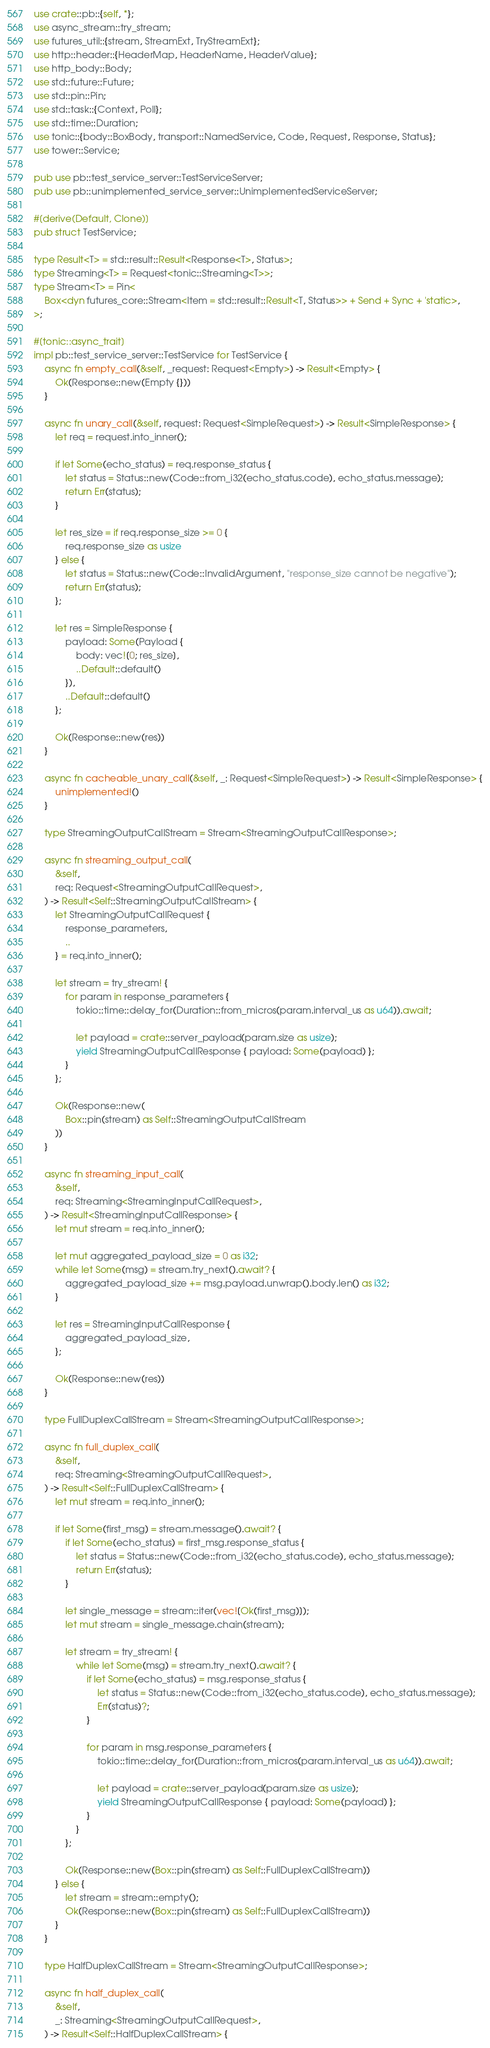Convert code to text. <code><loc_0><loc_0><loc_500><loc_500><_Rust_>use crate::pb::{self, *};
use async_stream::try_stream;
use futures_util::{stream, StreamExt, TryStreamExt};
use http::header::{HeaderMap, HeaderName, HeaderValue};
use http_body::Body;
use std::future::Future;
use std::pin::Pin;
use std::task::{Context, Poll};
use std::time::Duration;
use tonic::{body::BoxBody, transport::NamedService, Code, Request, Response, Status};
use tower::Service;

pub use pb::test_service_server::TestServiceServer;
pub use pb::unimplemented_service_server::UnimplementedServiceServer;

#[derive(Default, Clone)]
pub struct TestService;

type Result<T> = std::result::Result<Response<T>, Status>;
type Streaming<T> = Request<tonic::Streaming<T>>;
type Stream<T> = Pin<
    Box<dyn futures_core::Stream<Item = std::result::Result<T, Status>> + Send + Sync + 'static>,
>;

#[tonic::async_trait]
impl pb::test_service_server::TestService for TestService {
    async fn empty_call(&self, _request: Request<Empty>) -> Result<Empty> {
        Ok(Response::new(Empty {}))
    }

    async fn unary_call(&self, request: Request<SimpleRequest>) -> Result<SimpleResponse> {
        let req = request.into_inner();

        if let Some(echo_status) = req.response_status {
            let status = Status::new(Code::from_i32(echo_status.code), echo_status.message);
            return Err(status);
        }

        let res_size = if req.response_size >= 0 {
            req.response_size as usize
        } else {
            let status = Status::new(Code::InvalidArgument, "response_size cannot be negative");
            return Err(status);
        };

        let res = SimpleResponse {
            payload: Some(Payload {
                body: vec![0; res_size],
                ..Default::default()
            }),
            ..Default::default()
        };

        Ok(Response::new(res))
    }

    async fn cacheable_unary_call(&self, _: Request<SimpleRequest>) -> Result<SimpleResponse> {
        unimplemented!()
    }

    type StreamingOutputCallStream = Stream<StreamingOutputCallResponse>;

    async fn streaming_output_call(
        &self,
        req: Request<StreamingOutputCallRequest>,
    ) -> Result<Self::StreamingOutputCallStream> {
        let StreamingOutputCallRequest {
            response_parameters,
            ..
        } = req.into_inner();

        let stream = try_stream! {
            for param in response_parameters {
                tokio::time::delay_for(Duration::from_micros(param.interval_us as u64)).await;

                let payload = crate::server_payload(param.size as usize);
                yield StreamingOutputCallResponse { payload: Some(payload) };
            }
        };

        Ok(Response::new(
            Box::pin(stream) as Self::StreamingOutputCallStream
        ))
    }

    async fn streaming_input_call(
        &self,
        req: Streaming<StreamingInputCallRequest>,
    ) -> Result<StreamingInputCallResponse> {
        let mut stream = req.into_inner();

        let mut aggregated_payload_size = 0 as i32;
        while let Some(msg) = stream.try_next().await? {
            aggregated_payload_size += msg.payload.unwrap().body.len() as i32;
        }

        let res = StreamingInputCallResponse {
            aggregated_payload_size,
        };

        Ok(Response::new(res))
    }

    type FullDuplexCallStream = Stream<StreamingOutputCallResponse>;

    async fn full_duplex_call(
        &self,
        req: Streaming<StreamingOutputCallRequest>,
    ) -> Result<Self::FullDuplexCallStream> {
        let mut stream = req.into_inner();

        if let Some(first_msg) = stream.message().await? {
            if let Some(echo_status) = first_msg.response_status {
                let status = Status::new(Code::from_i32(echo_status.code), echo_status.message);
                return Err(status);
            }

            let single_message = stream::iter(vec![Ok(first_msg)]);
            let mut stream = single_message.chain(stream);

            let stream = try_stream! {
                while let Some(msg) = stream.try_next().await? {
                    if let Some(echo_status) = msg.response_status {
                        let status = Status::new(Code::from_i32(echo_status.code), echo_status.message);
                        Err(status)?;
                    }

                    for param in msg.response_parameters {
                        tokio::time::delay_for(Duration::from_micros(param.interval_us as u64)).await;

                        let payload = crate::server_payload(param.size as usize);
                        yield StreamingOutputCallResponse { payload: Some(payload) };
                    }
                }
            };

            Ok(Response::new(Box::pin(stream) as Self::FullDuplexCallStream))
        } else {
            let stream = stream::empty();
            Ok(Response::new(Box::pin(stream) as Self::FullDuplexCallStream))
        }
    }

    type HalfDuplexCallStream = Stream<StreamingOutputCallResponse>;

    async fn half_duplex_call(
        &self,
        _: Streaming<StreamingOutputCallRequest>,
    ) -> Result<Self::HalfDuplexCallStream> {</code> 